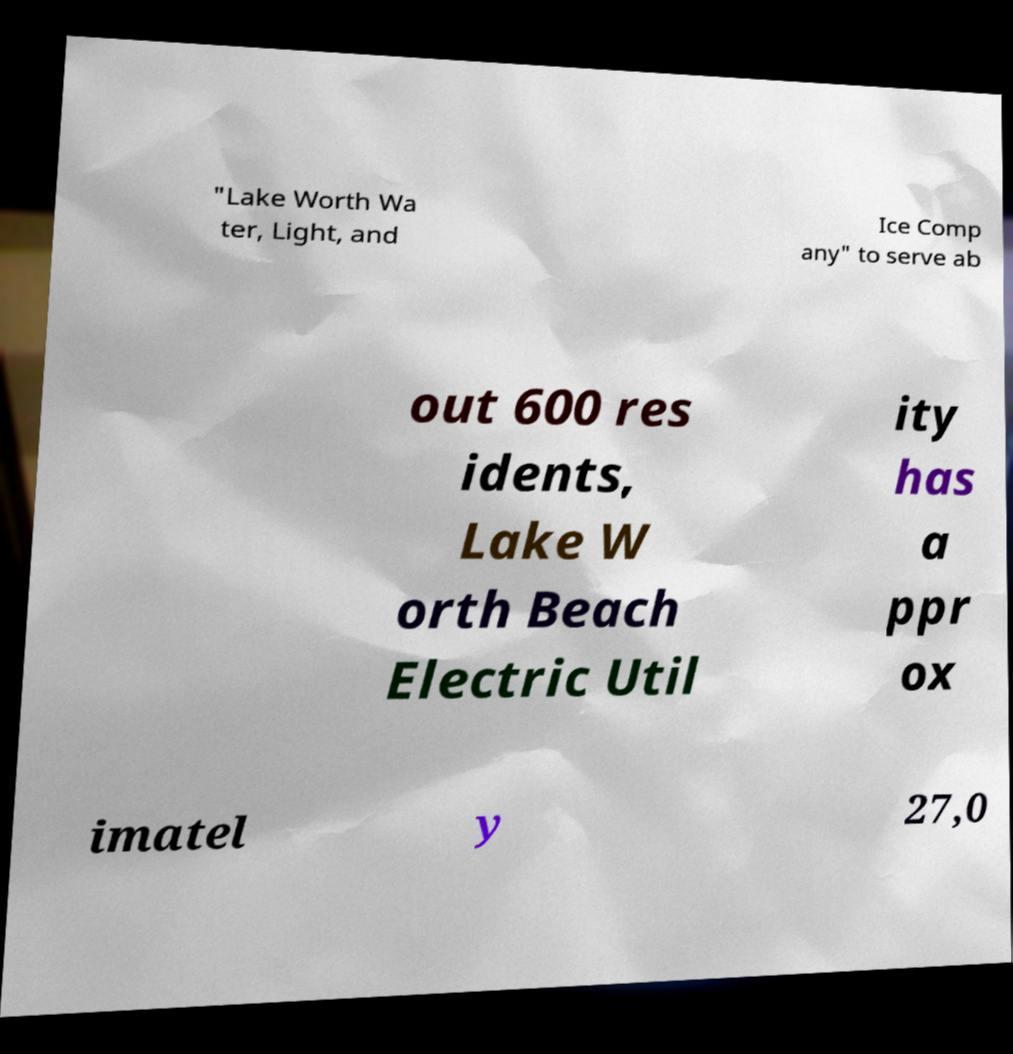For documentation purposes, I need the text within this image transcribed. Could you provide that? "Lake Worth Wa ter, Light, and Ice Comp any" to serve ab out 600 res idents, Lake W orth Beach Electric Util ity has a ppr ox imatel y 27,0 